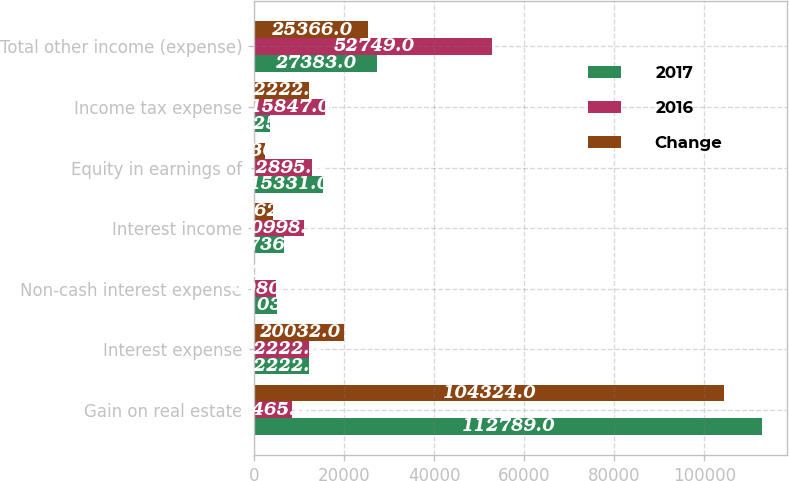Convert chart to OTSL. <chart><loc_0><loc_0><loc_500><loc_500><stacked_bar_chart><ecel><fcel>Gain on real estate<fcel>Interest expense<fcel>Non-cash interest expense<fcel>Interest income<fcel>Equity in earnings of<fcel>Income tax expense<fcel>Total other income (expense)<nl><fcel>2017<fcel>112789<fcel>12222<fcel>5103<fcel>6736<fcel>15331<fcel>3625<fcel>27383<nl><fcel>2016<fcel>8465<fcel>12222<fcel>4980<fcel>10998<fcel>12895<fcel>15847<fcel>52749<nl><fcel>Change<fcel>104324<fcel>20032<fcel>123<fcel>4262<fcel>2436<fcel>12222<fcel>25366<nl></chart> 